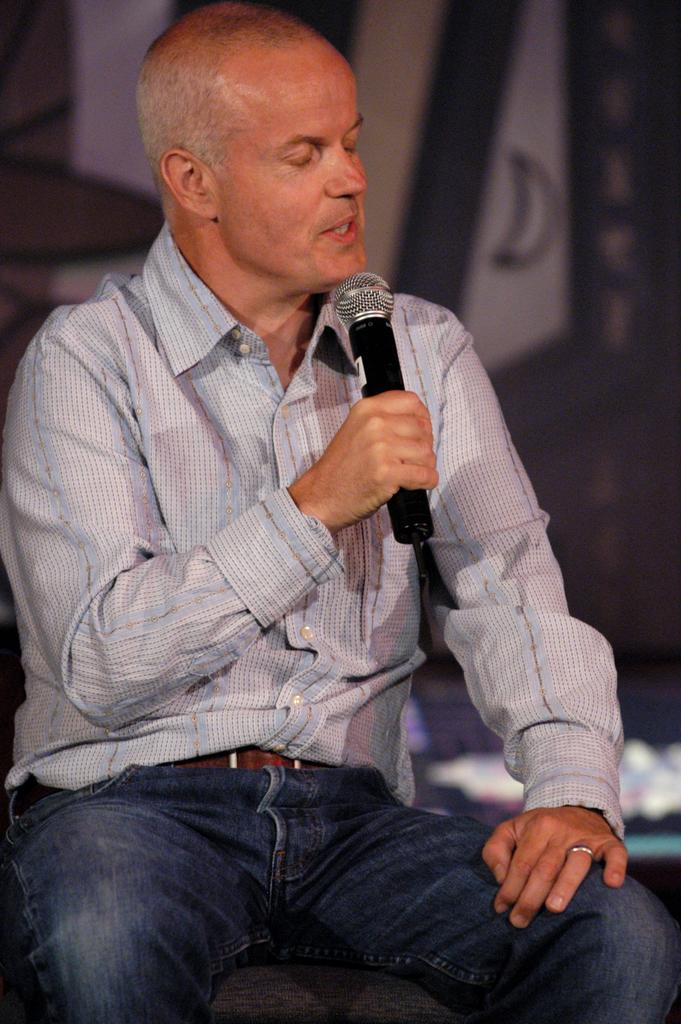Who is the main subject in the image? There is a man in the image. What is the man doing in the image? The man is sitting and talking on the mic. What object is the man holding in the image? The man is holding a mic. How does the man react to the earthquake in the image? There is no earthquake present in the image, so the man's reaction cannot be determined. 